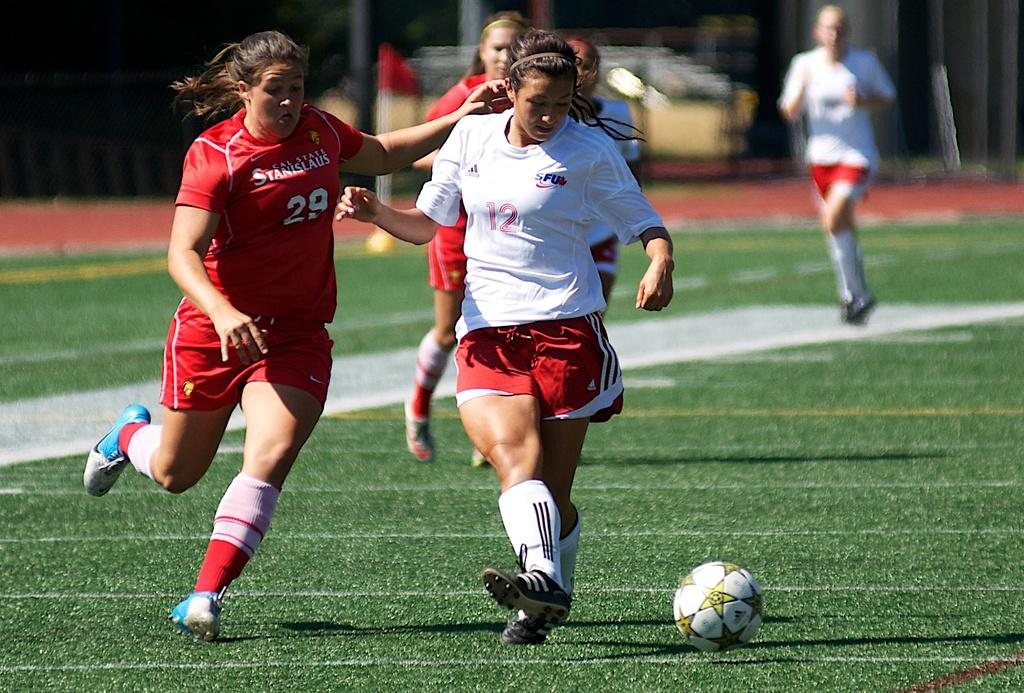Provide a one-sentence caption for the provided image. Soccer players going for a ball with one wearing a number 12 on her jersey. 